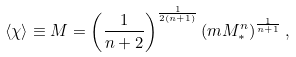<formula> <loc_0><loc_0><loc_500><loc_500>\langle \chi \rangle \equiv M = \left ( \frac { 1 } { n + 2 } \right ) ^ { \frac { 1 } { 2 ( n + 1 ) } } \left ( m M _ { * } ^ { n } \right ) ^ { \frac { 1 } { n + 1 } } ,</formula> 